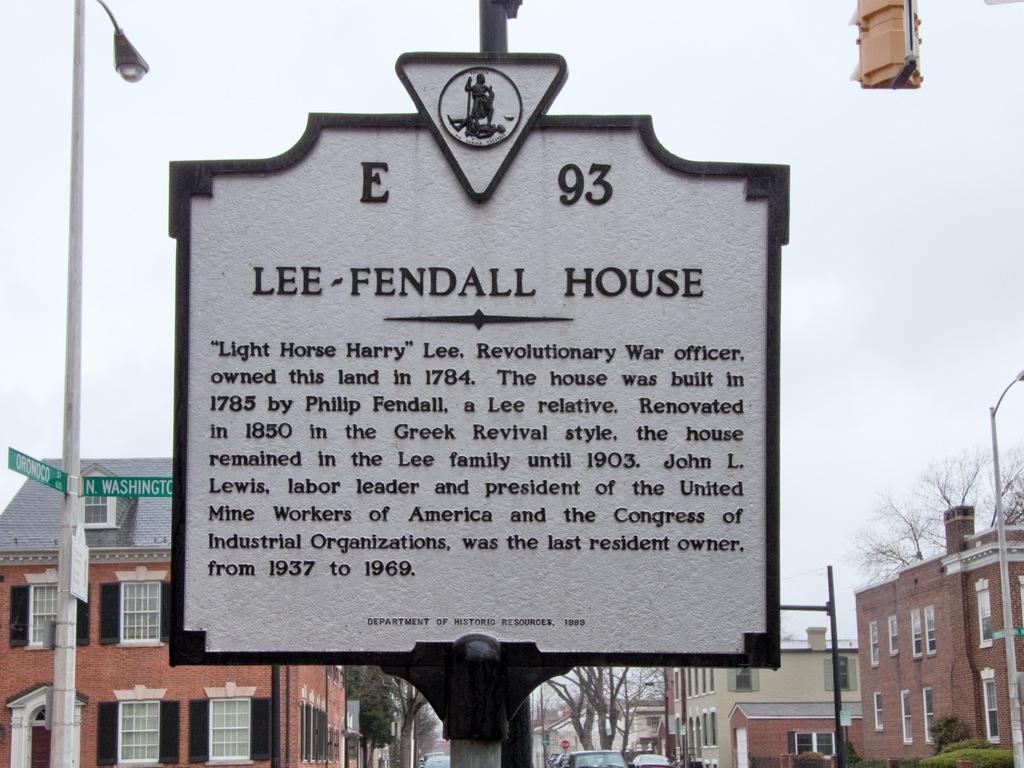Could you give a brief overview of what you see in this image? In the foreground I can see a board, light poles, plants and trees. In the background, I can see buildings, windows, vehicles on the road and the sky. This image is taken may be during a day. 